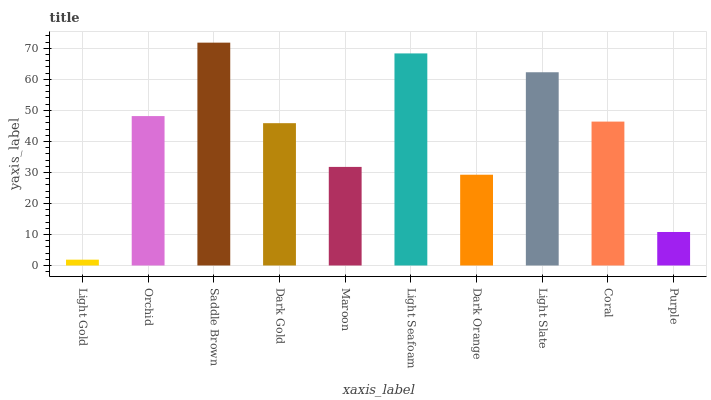Is Light Gold the minimum?
Answer yes or no. Yes. Is Saddle Brown the maximum?
Answer yes or no. Yes. Is Orchid the minimum?
Answer yes or no. No. Is Orchid the maximum?
Answer yes or no. No. Is Orchid greater than Light Gold?
Answer yes or no. Yes. Is Light Gold less than Orchid?
Answer yes or no. Yes. Is Light Gold greater than Orchid?
Answer yes or no. No. Is Orchid less than Light Gold?
Answer yes or no. No. Is Coral the high median?
Answer yes or no. Yes. Is Dark Gold the low median?
Answer yes or no. Yes. Is Light Seafoam the high median?
Answer yes or no. No. Is Light Seafoam the low median?
Answer yes or no. No. 